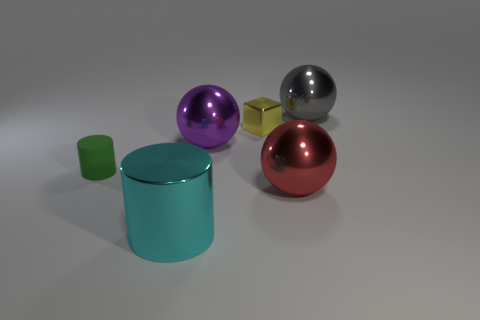Can you describe the shapes and colors visible in the image? Certainly! The image presents an array of geometric shapes including a large cyan cylinder, a large purple sphere, a large red sphere, and a small green cylinder. There's also a small yellow cube.  Could you guess the possible materials of these objects? Based on the reflections and shadows in the image, the objects appear to be made of a shiny, perhaps metallic or plastic material, which gives them a reflective and smooth surface. 